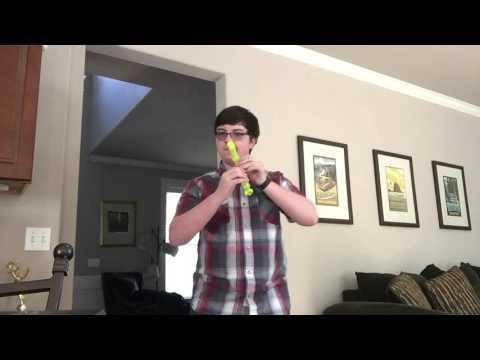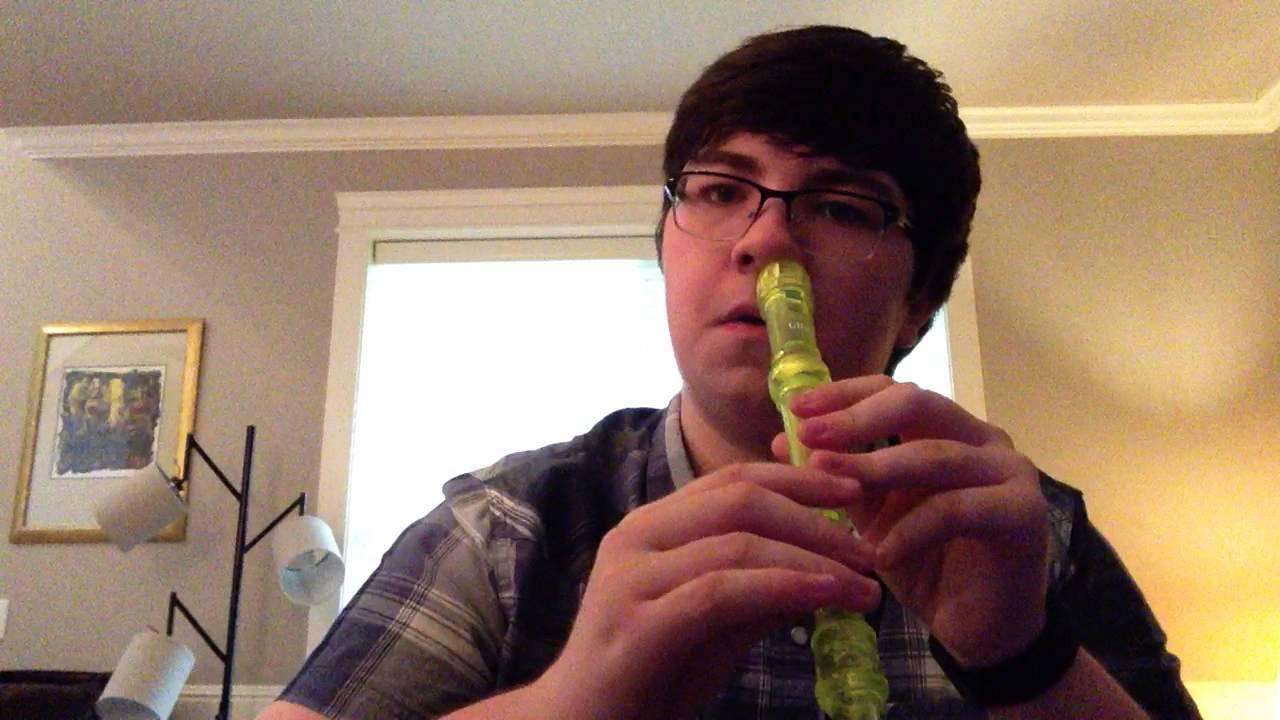The first image is the image on the left, the second image is the image on the right. For the images displayed, is the sentence "The left and right image contains the same number of men playing the flute and at least one man is wearing a green hat." factually correct? Answer yes or no. No. The first image is the image on the left, the second image is the image on the right. Given the left and right images, does the statement "Each image shows a male holding a flute to one nostril, and the right image features a man in a green frog-eye head covering and white shirt." hold true? Answer yes or no. No. 